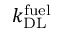Convert formula to latex. <formula><loc_0><loc_0><loc_500><loc_500>k _ { D L } ^ { f u e l }</formula> 